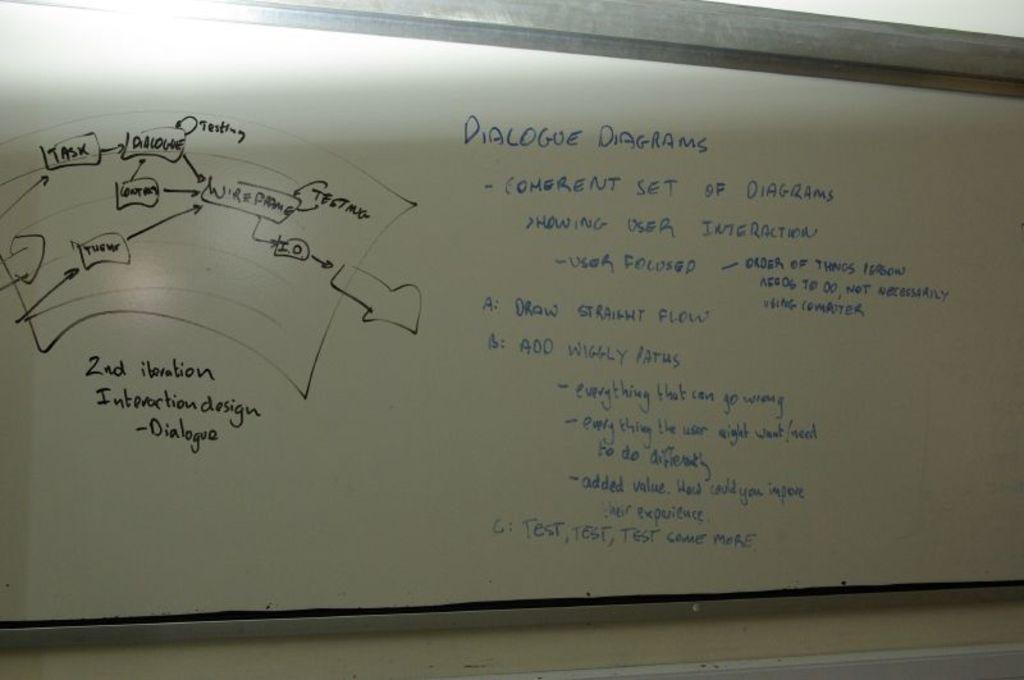<image>
Write a terse but informative summary of the picture. A white board has writing on it that explains dialogue diagrams. 